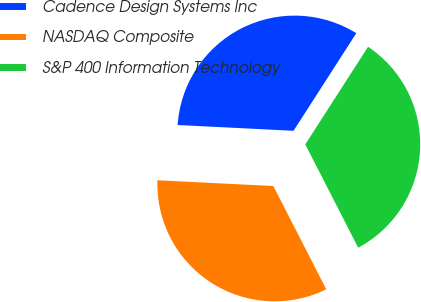Convert chart to OTSL. <chart><loc_0><loc_0><loc_500><loc_500><pie_chart><fcel>Cadence Design Systems Inc<fcel>NASDAQ Composite<fcel>S&P 400 Information Technology<nl><fcel>33.3%<fcel>33.33%<fcel>33.37%<nl></chart> 